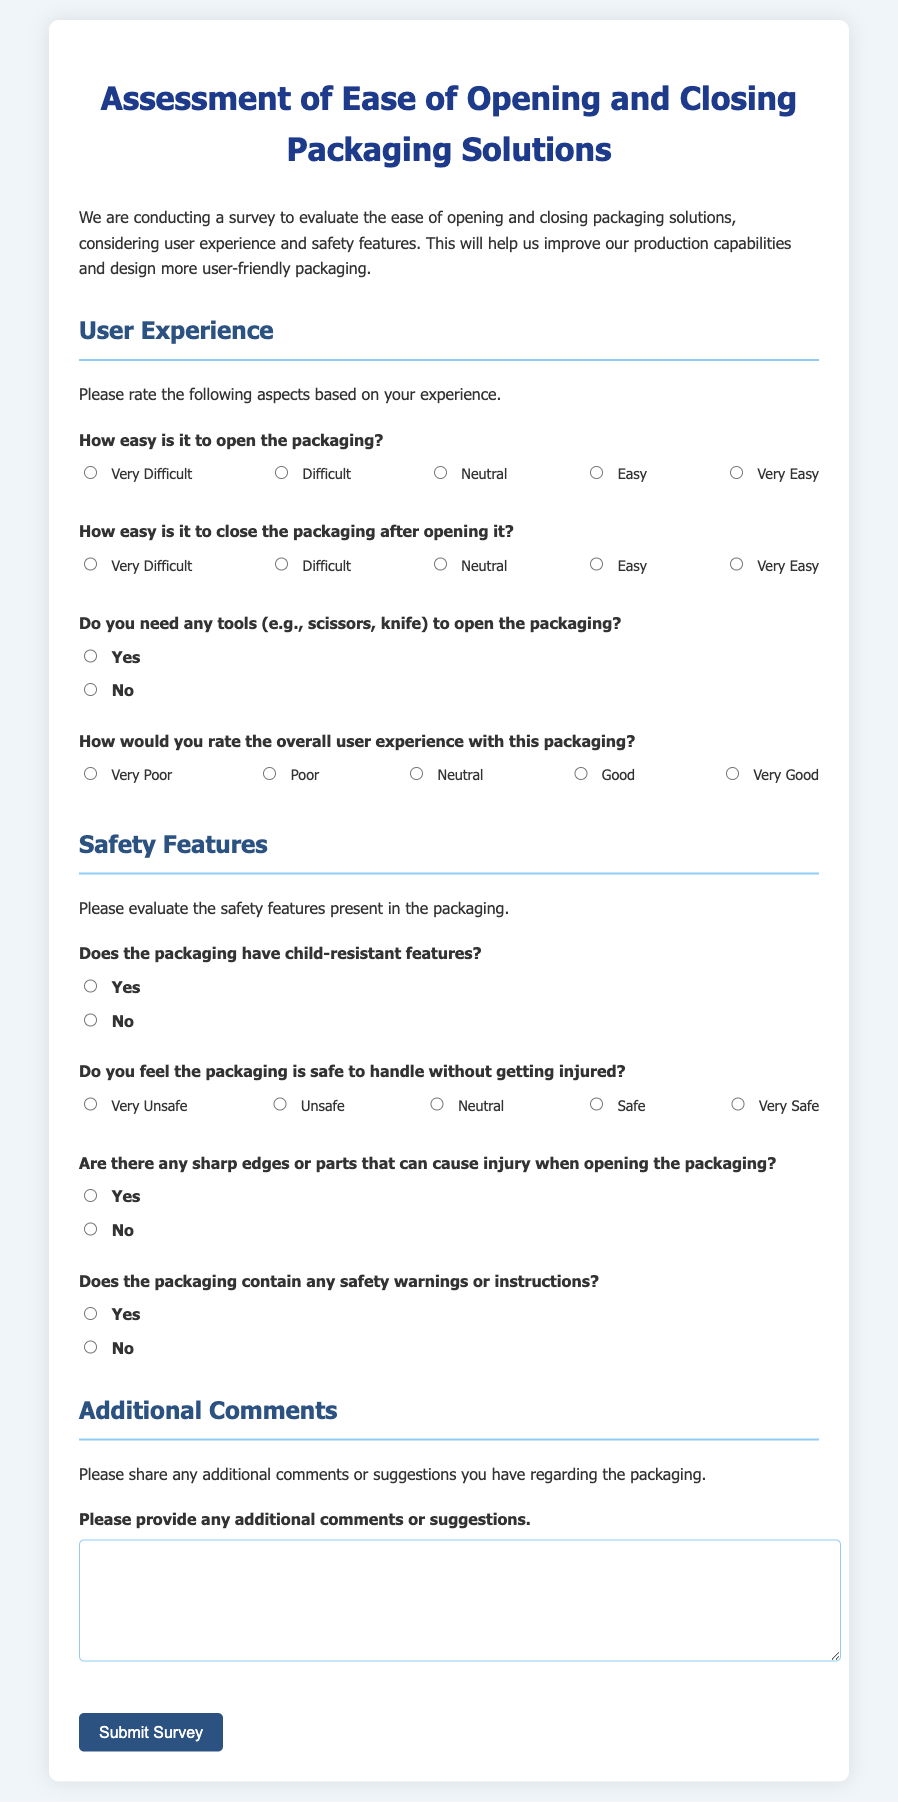What is the title of the survey? The title of the survey is provided at the top of the rendered document.
Answer: Assessment of Ease of Opening and Closing Packaging Solutions How many questions are in the 'User Experience' section? The 'User Experience' section includes multiple questions displayed in the survey.
Answer: Four What is the rating scale for 'How easy is it to close the packaging after opening it?' The rating scale for this question consists of five possible responses ranging from very difficult to very easy.
Answer: 1 to 5 Are there safety warnings or instructions in the packaging? This question is explicitly asked in the safety features section of the survey.
Answer: Yes or No What does the submit button say? The submit button in the form is always labeled to indicate its function clearly.
Answer: Submit Survey How is overall user experience rated in the survey? This aspect is covered by a specific question where users provide a rating between very poor to very good.
Answer: 1 to 5 